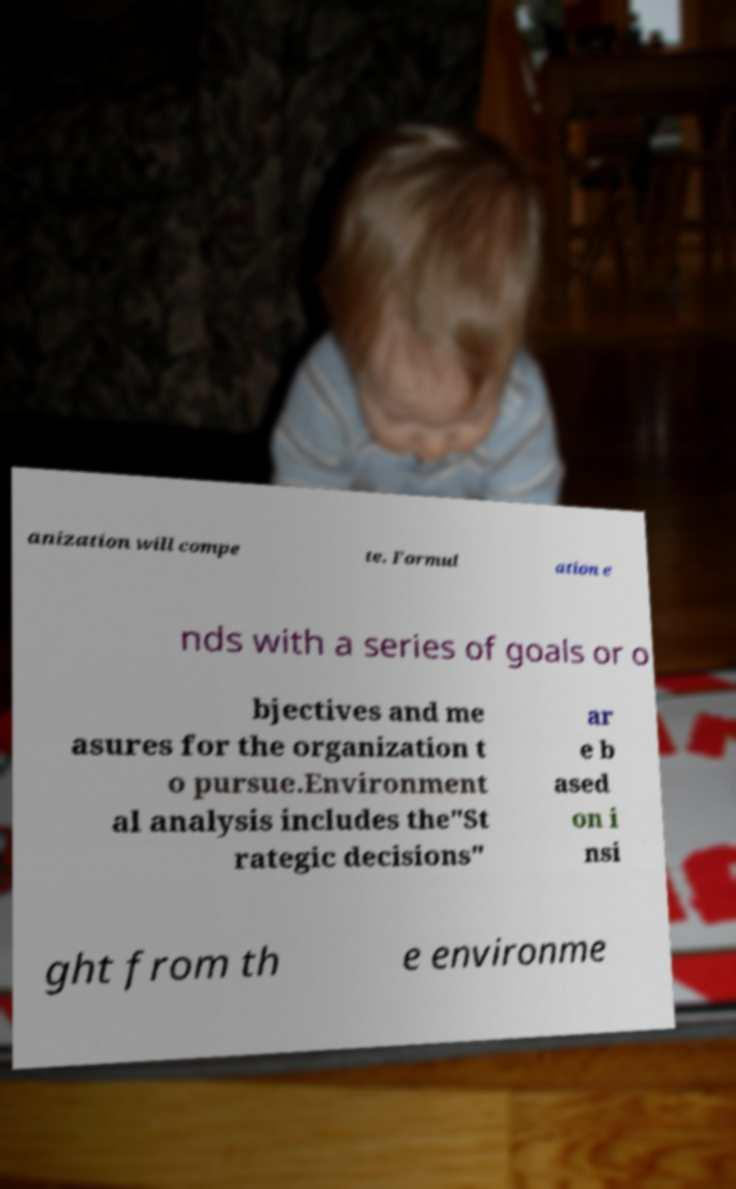There's text embedded in this image that I need extracted. Can you transcribe it verbatim? anization will compe te. Formul ation e nds with a series of goals or o bjectives and me asures for the organization t o pursue.Environment al analysis includes the"St rategic decisions" ar e b ased on i nsi ght from th e environme 